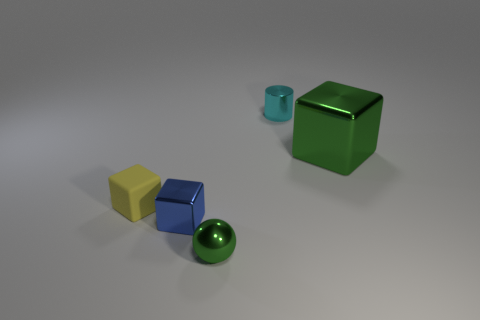There is a green object on the right side of the tiny object behind the metallic block right of the green sphere; what is it made of? The green object you're referring to, situated behind the small object and to the right of the green sphere, appears to be made of a smooth, reflective material consistent with metal. 